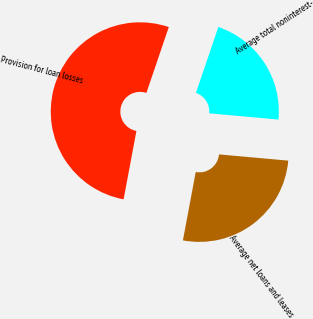Convert chart. <chart><loc_0><loc_0><loc_500><loc_500><pie_chart><fcel>Average net loans and leases<fcel>Average total noninterest-<fcel>Provision for loan losses<nl><fcel>26.52%<fcel>21.21%<fcel>52.27%<nl></chart> 